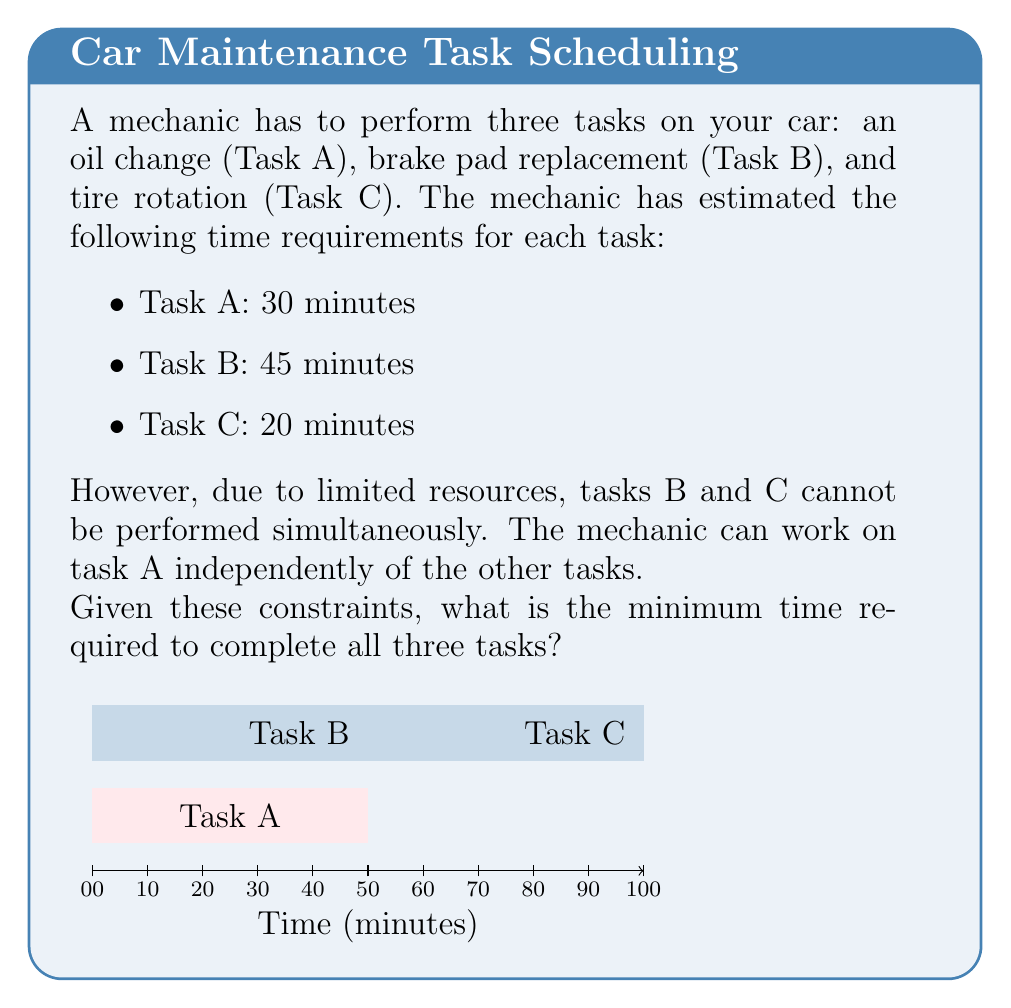Teach me how to tackle this problem. Let's approach this step-by-step:

1) First, we need to understand the constraints:
   - Task A can be done independently
   - Tasks B and C cannot be done simultaneously

2) Given these constraints, we have two possible scenarios:
   a) Do Task A first, then B and C
   b) Do Tasks B and C first, then A

3) Let's calculate the time for each scenario:

   Scenario a:
   $$ T_a = T_A + T_B + T_C = 30 + 45 + 20 = 95 \text{ minutes} $$

   Scenario b:
   $$ T_b = \max(T_A, T_B + T_C) = \max(30, 45 + 20) = \max(30, 65) = 65 \text{ minutes} $$

4) In Scenario b, we can start Task A immediately and it will finish before Tasks B and C are completed. This allows for parallel processing, reducing the total time.

5) Therefore, the minimum time required is given by Scenario b:

   $$ T_{min} = \max(T_A, T_B + T_C) = 65 \text{ minutes} $$

This solution optimizes the use of the mechanic's time by performing tasks in parallel when possible, while respecting the constraint that Tasks B and C cannot be done simultaneously.
Answer: 65 minutes 